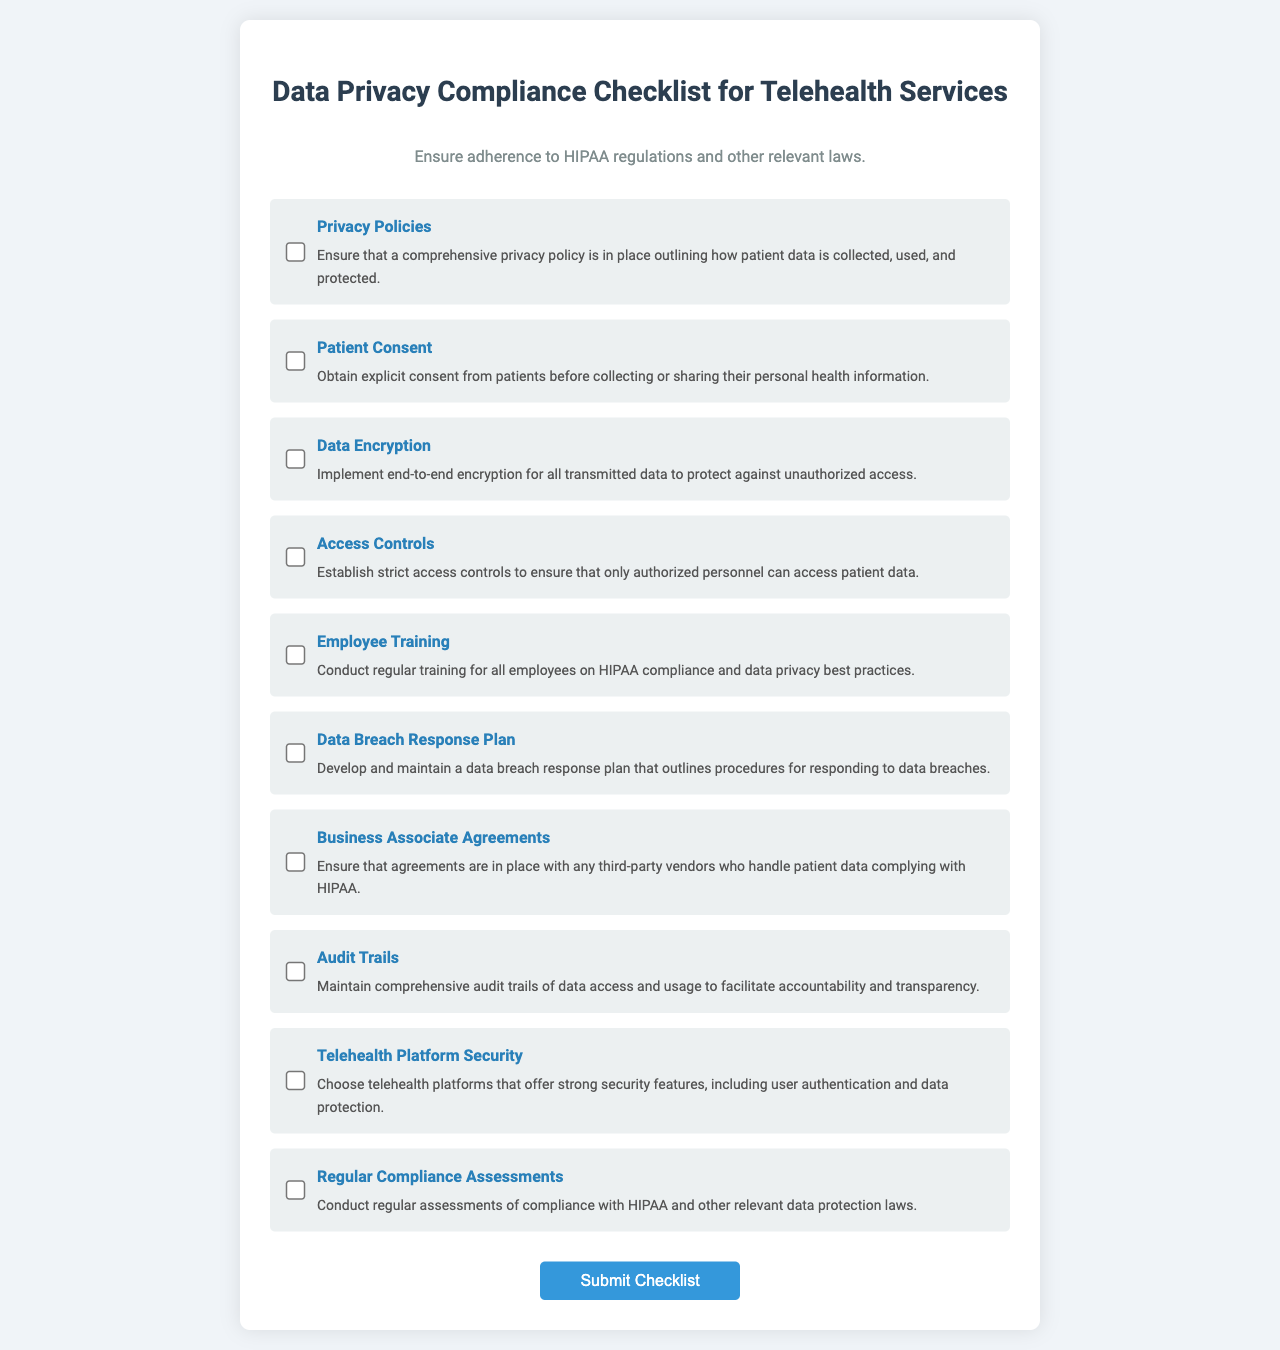What is the title of the checklist? The title of the checklist is what is prominently displayed at the top of the document, indicating the purpose of the content.
Answer: Data Privacy Compliance Checklist for Telehealth Services How many checklist items are there? The number of checklist items is the total count of the individual items listed under the checklist section of the document.
Answer: 9 What is the requirement for employee training? The requirement for employee training is a specific action outlined in the checklist regarding training for staff.
Answer: Conduct regular training for all employees on HIPAA compliance and data privacy best practices What type of agreements should be ensured with third-party vendors? The type of agreements mentioned is crucial for compliance with HIPAA and is specified in the checklist item about vendor relationships.
Answer: Business Associate Agreements What does the data breach response plan outline? This question asks for the main focus of the data breach response plan as described in the checklist.
Answer: Procedures for responding to data breaches What security features are mentioned for telehealth platforms? This question pertains to the specific capabilities that must be included in the telehealth platforms as per the checklist.
Answer: Strong security features, including user authentication and data protection What should be maintained to ensure accountability and transparency? This question looks for a specific item in the checklist that relates to tracking data access and its usage.
Answer: Comprehensive audit trails What is the purpose of conducting regular compliance assessments? This question relates to what the regular compliance assessments aim to achieve as described in the checklist.
Answer: Compliance with HIPAA and other relevant data protection laws 